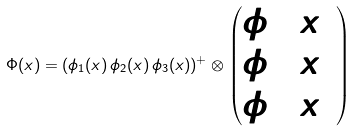<formula> <loc_0><loc_0><loc_500><loc_500>\Phi ( x ) = ( \phi _ { 1 } ( x ) \, \phi _ { 2 } ( x ) \, \phi _ { 3 } ( x ) ) ^ { + } \otimes \begin{pmatrix} \phi _ { 1 } ( x ) \\ \phi _ { 2 } ( x ) \\ \phi _ { 3 } ( x ) \end{pmatrix}</formula> 